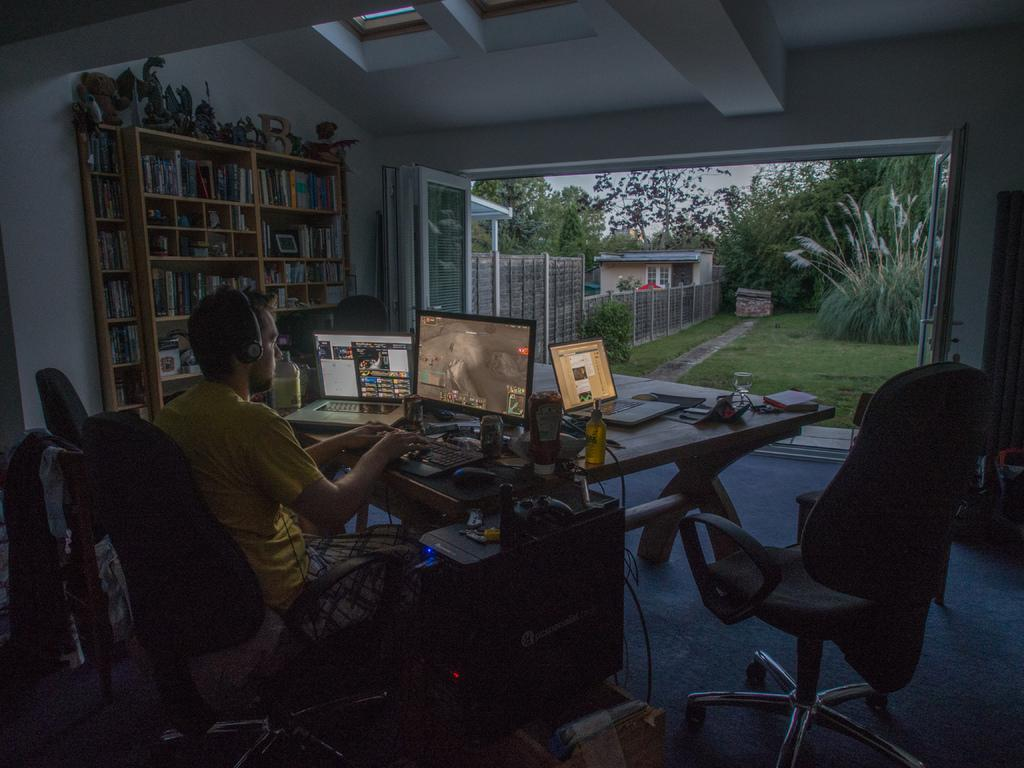What is the person in the image doing? The person is working on a laptop. What is the person using to work on in the image? The person is using a laptop and a system, both of which are on a table. What can be seen outside the room in the image? There is a garden visible near the room. Where is the kettle located in the image? There is no kettle present in the image. What type of drawer can be seen in the image? There are no drawers visible in the image. 